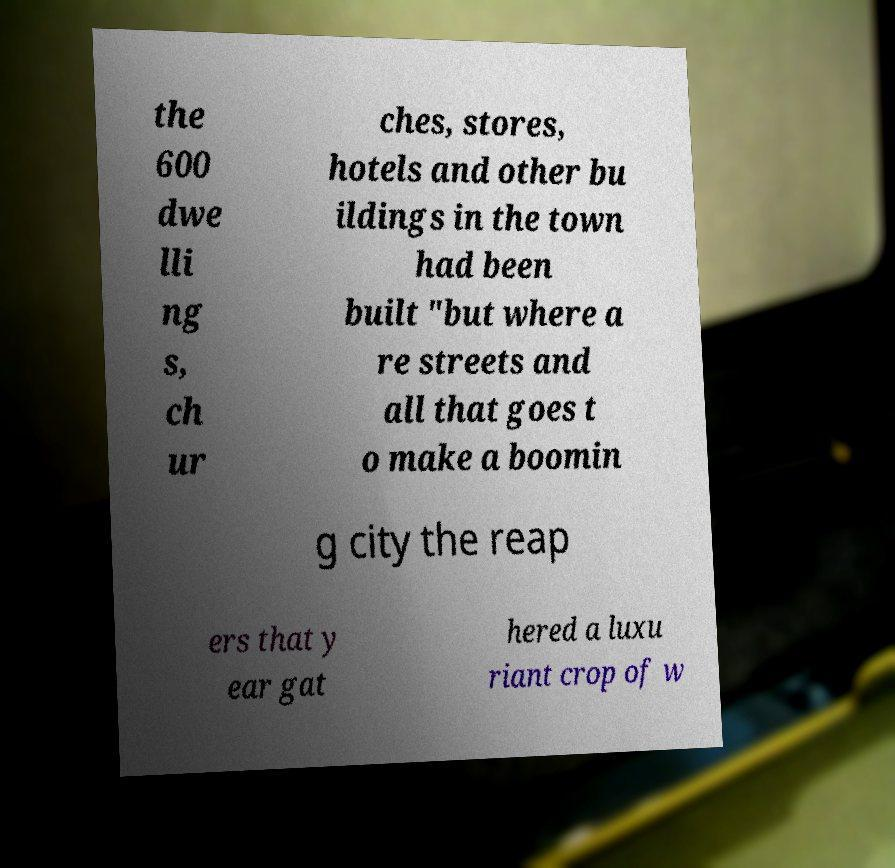Could you assist in decoding the text presented in this image and type it out clearly? the 600 dwe lli ng s, ch ur ches, stores, hotels and other bu ildings in the town had been built "but where a re streets and all that goes t o make a boomin g city the reap ers that y ear gat hered a luxu riant crop of w 